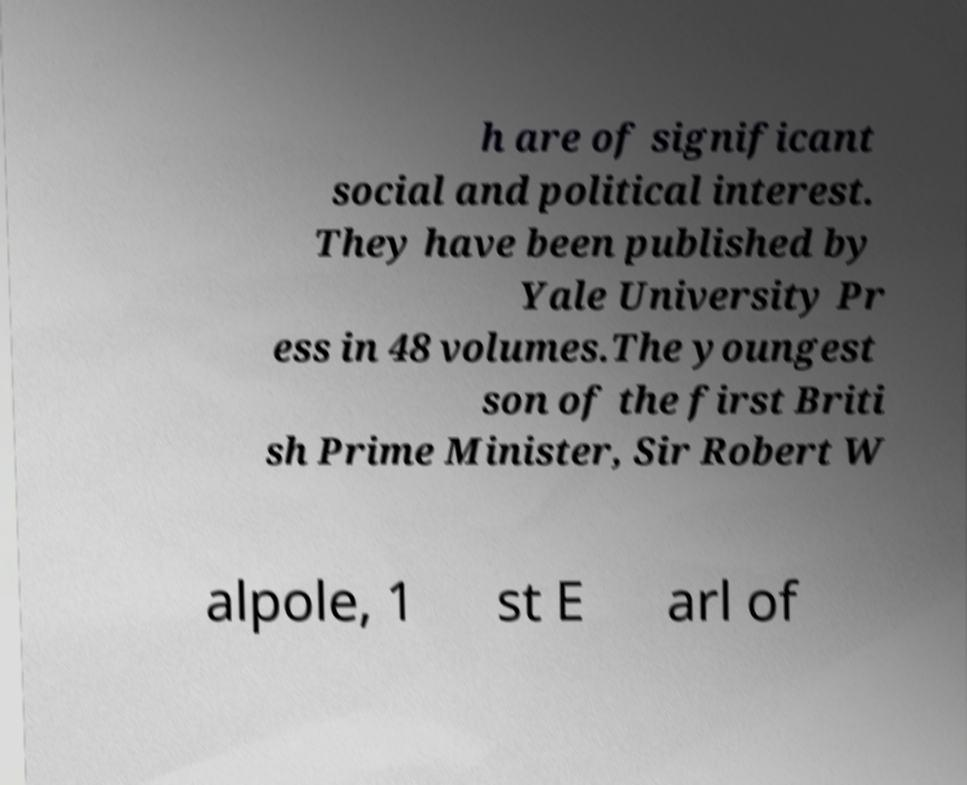What messages or text are displayed in this image? I need them in a readable, typed format. h are of significant social and political interest. They have been published by Yale University Pr ess in 48 volumes.The youngest son of the first Briti sh Prime Minister, Sir Robert W alpole, 1 st E arl of 